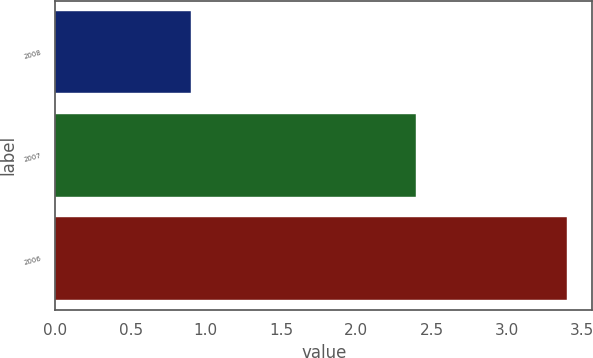<chart> <loc_0><loc_0><loc_500><loc_500><bar_chart><fcel>2008<fcel>2007<fcel>2006<nl><fcel>0.9<fcel>2.4<fcel>3.4<nl></chart> 